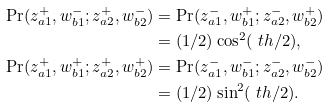<formula> <loc_0><loc_0><loc_500><loc_500>\Pr ( z _ { a 1 } ^ { + } , w _ { b 1 } ^ { - } ; z _ { a 2 } ^ { + } , w _ { b 2 } ^ { - } ) & = \Pr ( z _ { a 1 } ^ { - } , w _ { b 1 } ^ { + } ; z _ { a 2 } ^ { - } , w _ { b 2 } ^ { + } ) \\ & = ( 1 / 2 ) \cos ^ { 2 } ( \ t h / 2 ) , \\ \Pr ( z _ { a 1 } ^ { + } , w _ { b 1 } ^ { + } ; z _ { a 2 } ^ { + } , w _ { b 2 } ^ { + } ) & = \Pr ( z _ { a 1 } ^ { - } , w _ { b 1 } ^ { - } ; z _ { a 2 } ^ { - } , w _ { b 2 } ^ { - } ) \\ & = ( 1 / 2 ) \sin ^ { 2 } ( \ t h / 2 ) .</formula> 